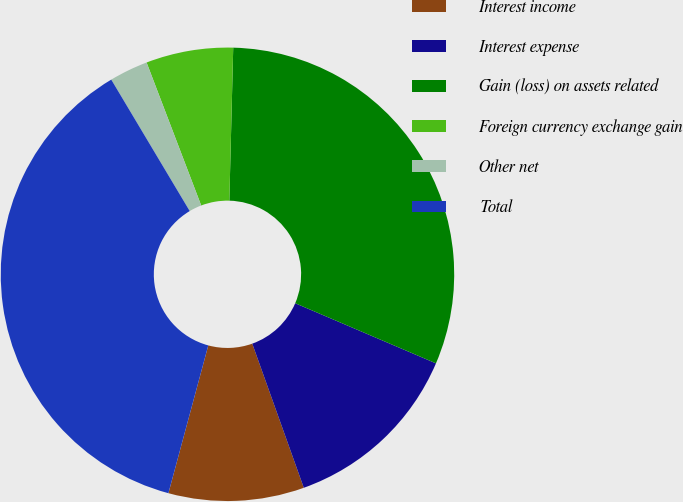Convert chart to OTSL. <chart><loc_0><loc_0><loc_500><loc_500><pie_chart><fcel>Interest income<fcel>Interest expense<fcel>Gain (loss) on assets related<fcel>Foreign currency exchange gain<fcel>Other net<fcel>Total<nl><fcel>9.66%<fcel>13.11%<fcel>31.02%<fcel>6.21%<fcel>2.76%<fcel>37.24%<nl></chart> 